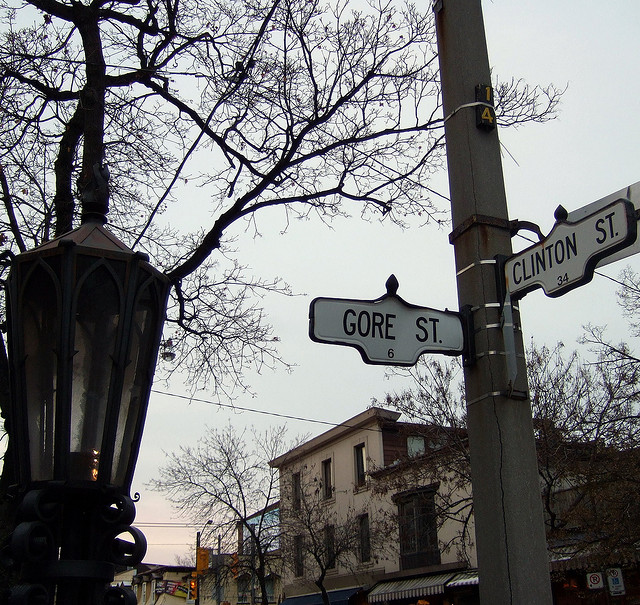Identify and read out the text in this image. GORE ST CLINTON ST 34 4 6 